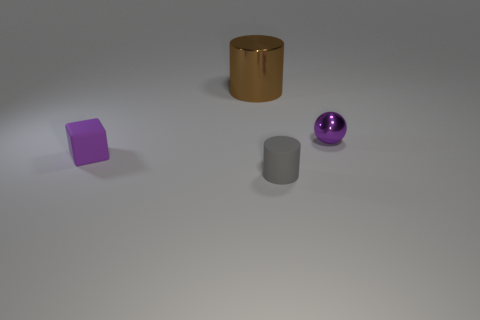Subtract 1 cylinders. How many cylinders are left? 1 Subtract all brown cylinders. How many cylinders are left? 1 Subtract all blocks. How many objects are left? 3 Subtract all cyan cubes. How many purple cylinders are left? 0 Subtract all tiny purple rubber blocks. Subtract all tiny gray shiny cubes. How many objects are left? 3 Add 2 tiny purple objects. How many tiny purple objects are left? 4 Add 1 tiny cyan cylinders. How many tiny cyan cylinders exist? 1 Add 3 gray cubes. How many objects exist? 7 Subtract 0 yellow cubes. How many objects are left? 4 Subtract all purple cylinders. Subtract all cyan balls. How many cylinders are left? 2 